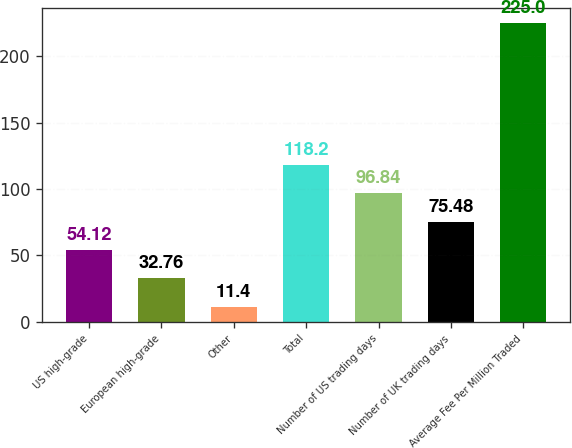<chart> <loc_0><loc_0><loc_500><loc_500><bar_chart><fcel>US high-grade<fcel>European high-grade<fcel>Other<fcel>Total<fcel>Number of US trading days<fcel>Number of UK trading days<fcel>Average Fee Per Million Traded<nl><fcel>54.12<fcel>32.76<fcel>11.4<fcel>118.2<fcel>96.84<fcel>75.48<fcel>225<nl></chart> 